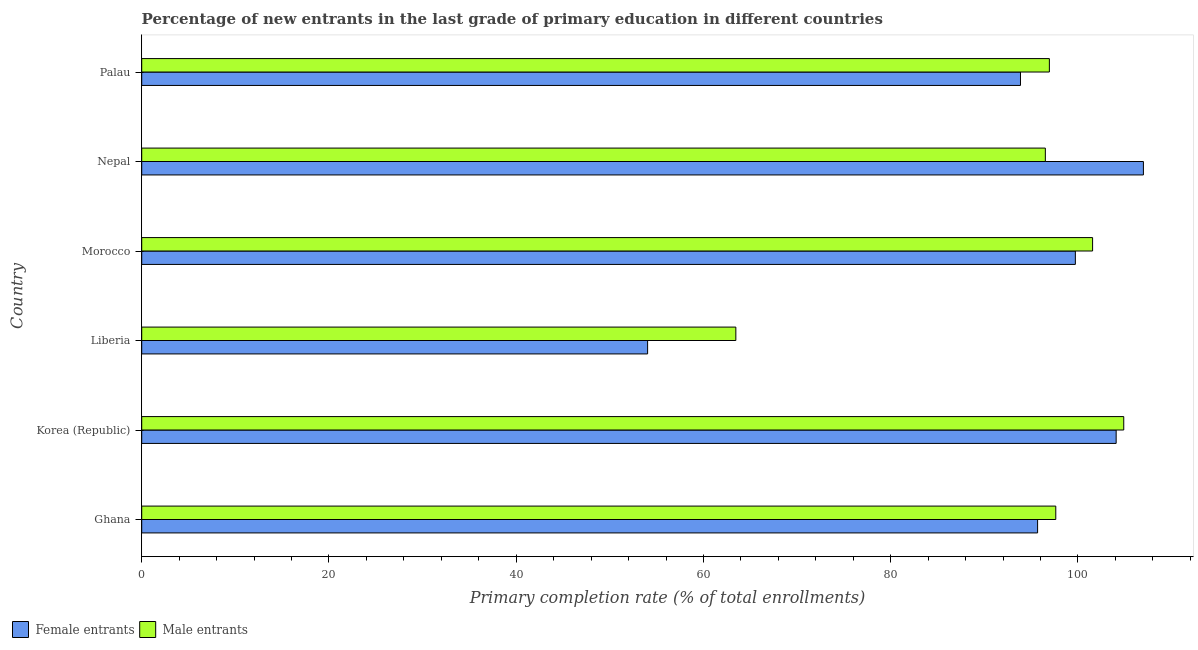How many groups of bars are there?
Provide a succinct answer. 6. Are the number of bars per tick equal to the number of legend labels?
Offer a terse response. Yes. How many bars are there on the 5th tick from the top?
Make the answer very short. 2. How many bars are there on the 4th tick from the bottom?
Provide a short and direct response. 2. What is the primary completion rate of female entrants in Palau?
Offer a very short reply. 93.86. Across all countries, what is the maximum primary completion rate of female entrants?
Keep it short and to the point. 106.99. Across all countries, what is the minimum primary completion rate of male entrants?
Provide a succinct answer. 63.46. In which country was the primary completion rate of male entrants maximum?
Your answer should be compact. Korea (Republic). In which country was the primary completion rate of male entrants minimum?
Your answer should be very brief. Liberia. What is the total primary completion rate of male entrants in the graph?
Make the answer very short. 561. What is the difference between the primary completion rate of male entrants in Liberia and that in Nepal?
Offer a terse response. -33.06. What is the difference between the primary completion rate of male entrants in Morocco and the primary completion rate of female entrants in Nepal?
Your answer should be compact. -5.43. What is the average primary completion rate of female entrants per country?
Ensure brevity in your answer.  92.39. What is the difference between the primary completion rate of male entrants and primary completion rate of female entrants in Palau?
Provide a succinct answer. 3.09. In how many countries, is the primary completion rate of male entrants greater than 84 %?
Provide a succinct answer. 5. What is the ratio of the primary completion rate of male entrants in Korea (Republic) to that in Liberia?
Your answer should be very brief. 1.65. Is the primary completion rate of female entrants in Korea (Republic) less than that in Nepal?
Give a very brief answer. Yes. Is the difference between the primary completion rate of male entrants in Ghana and Liberia greater than the difference between the primary completion rate of female entrants in Ghana and Liberia?
Make the answer very short. No. What is the difference between the highest and the second highest primary completion rate of male entrants?
Your answer should be compact. 3.33. What is the difference between the highest and the lowest primary completion rate of female entrants?
Offer a terse response. 52.96. Is the sum of the primary completion rate of male entrants in Nepal and Palau greater than the maximum primary completion rate of female entrants across all countries?
Make the answer very short. Yes. What does the 1st bar from the top in Nepal represents?
Keep it short and to the point. Male entrants. What does the 2nd bar from the bottom in Korea (Republic) represents?
Make the answer very short. Male entrants. How many bars are there?
Provide a short and direct response. 12. Are all the bars in the graph horizontal?
Provide a succinct answer. Yes. What is the difference between two consecutive major ticks on the X-axis?
Your response must be concise. 20. Are the values on the major ticks of X-axis written in scientific E-notation?
Give a very brief answer. No. How many legend labels are there?
Your answer should be compact. 2. How are the legend labels stacked?
Your answer should be compact. Horizontal. What is the title of the graph?
Your response must be concise. Percentage of new entrants in the last grade of primary education in different countries. Does "Fixed telephone" appear as one of the legend labels in the graph?
Give a very brief answer. No. What is the label or title of the X-axis?
Offer a terse response. Primary completion rate (% of total enrollments). What is the label or title of the Y-axis?
Make the answer very short. Country. What is the Primary completion rate (% of total enrollments) in Female entrants in Ghana?
Your response must be concise. 95.69. What is the Primary completion rate (% of total enrollments) of Male entrants in Ghana?
Offer a terse response. 97.63. What is the Primary completion rate (% of total enrollments) in Female entrants in Korea (Republic)?
Provide a short and direct response. 104.08. What is the Primary completion rate (% of total enrollments) of Male entrants in Korea (Republic)?
Provide a short and direct response. 104.89. What is the Primary completion rate (% of total enrollments) of Female entrants in Liberia?
Ensure brevity in your answer.  54.03. What is the Primary completion rate (% of total enrollments) in Male entrants in Liberia?
Give a very brief answer. 63.46. What is the Primary completion rate (% of total enrollments) of Female entrants in Morocco?
Provide a succinct answer. 99.72. What is the Primary completion rate (% of total enrollments) in Male entrants in Morocco?
Offer a terse response. 101.56. What is the Primary completion rate (% of total enrollments) in Female entrants in Nepal?
Keep it short and to the point. 106.99. What is the Primary completion rate (% of total enrollments) in Male entrants in Nepal?
Offer a very short reply. 96.52. What is the Primary completion rate (% of total enrollments) of Female entrants in Palau?
Your answer should be compact. 93.86. What is the Primary completion rate (% of total enrollments) of Male entrants in Palau?
Provide a short and direct response. 96.95. Across all countries, what is the maximum Primary completion rate (% of total enrollments) of Female entrants?
Your answer should be very brief. 106.99. Across all countries, what is the maximum Primary completion rate (% of total enrollments) in Male entrants?
Make the answer very short. 104.89. Across all countries, what is the minimum Primary completion rate (% of total enrollments) of Female entrants?
Provide a succinct answer. 54.03. Across all countries, what is the minimum Primary completion rate (% of total enrollments) in Male entrants?
Your answer should be very brief. 63.46. What is the total Primary completion rate (% of total enrollments) in Female entrants in the graph?
Give a very brief answer. 554.37. What is the total Primary completion rate (% of total enrollments) in Male entrants in the graph?
Offer a terse response. 561. What is the difference between the Primary completion rate (% of total enrollments) of Female entrants in Ghana and that in Korea (Republic)?
Make the answer very short. -8.39. What is the difference between the Primary completion rate (% of total enrollments) of Male entrants in Ghana and that in Korea (Republic)?
Give a very brief answer. -7.26. What is the difference between the Primary completion rate (% of total enrollments) of Female entrants in Ghana and that in Liberia?
Provide a succinct answer. 41.65. What is the difference between the Primary completion rate (% of total enrollments) of Male entrants in Ghana and that in Liberia?
Provide a succinct answer. 34.17. What is the difference between the Primary completion rate (% of total enrollments) in Female entrants in Ghana and that in Morocco?
Keep it short and to the point. -4.03. What is the difference between the Primary completion rate (% of total enrollments) in Male entrants in Ghana and that in Morocco?
Give a very brief answer. -3.93. What is the difference between the Primary completion rate (% of total enrollments) of Female entrants in Ghana and that in Nepal?
Provide a succinct answer. -11.3. What is the difference between the Primary completion rate (% of total enrollments) in Male entrants in Ghana and that in Nepal?
Offer a very short reply. 1.11. What is the difference between the Primary completion rate (% of total enrollments) of Female entrants in Ghana and that in Palau?
Keep it short and to the point. 1.83. What is the difference between the Primary completion rate (% of total enrollments) of Male entrants in Ghana and that in Palau?
Offer a very short reply. 0.68. What is the difference between the Primary completion rate (% of total enrollments) of Female entrants in Korea (Republic) and that in Liberia?
Your answer should be compact. 50.04. What is the difference between the Primary completion rate (% of total enrollments) in Male entrants in Korea (Republic) and that in Liberia?
Keep it short and to the point. 41.43. What is the difference between the Primary completion rate (% of total enrollments) in Female entrants in Korea (Republic) and that in Morocco?
Give a very brief answer. 4.36. What is the difference between the Primary completion rate (% of total enrollments) in Male entrants in Korea (Republic) and that in Morocco?
Give a very brief answer. 3.33. What is the difference between the Primary completion rate (% of total enrollments) of Female entrants in Korea (Republic) and that in Nepal?
Your response must be concise. -2.91. What is the difference between the Primary completion rate (% of total enrollments) in Male entrants in Korea (Republic) and that in Nepal?
Your answer should be compact. 8.37. What is the difference between the Primary completion rate (% of total enrollments) in Female entrants in Korea (Republic) and that in Palau?
Offer a very short reply. 10.22. What is the difference between the Primary completion rate (% of total enrollments) in Male entrants in Korea (Republic) and that in Palau?
Your answer should be compact. 7.94. What is the difference between the Primary completion rate (% of total enrollments) of Female entrants in Liberia and that in Morocco?
Offer a terse response. -45.69. What is the difference between the Primary completion rate (% of total enrollments) of Male entrants in Liberia and that in Morocco?
Your answer should be very brief. -38.11. What is the difference between the Primary completion rate (% of total enrollments) in Female entrants in Liberia and that in Nepal?
Your answer should be compact. -52.96. What is the difference between the Primary completion rate (% of total enrollments) in Male entrants in Liberia and that in Nepal?
Make the answer very short. -33.06. What is the difference between the Primary completion rate (% of total enrollments) of Female entrants in Liberia and that in Palau?
Keep it short and to the point. -39.83. What is the difference between the Primary completion rate (% of total enrollments) of Male entrants in Liberia and that in Palau?
Provide a succinct answer. -33.49. What is the difference between the Primary completion rate (% of total enrollments) in Female entrants in Morocco and that in Nepal?
Give a very brief answer. -7.27. What is the difference between the Primary completion rate (% of total enrollments) of Male entrants in Morocco and that in Nepal?
Provide a succinct answer. 5.05. What is the difference between the Primary completion rate (% of total enrollments) of Female entrants in Morocco and that in Palau?
Your answer should be compact. 5.86. What is the difference between the Primary completion rate (% of total enrollments) in Male entrants in Morocco and that in Palau?
Provide a succinct answer. 4.62. What is the difference between the Primary completion rate (% of total enrollments) of Female entrants in Nepal and that in Palau?
Offer a very short reply. 13.13. What is the difference between the Primary completion rate (% of total enrollments) in Male entrants in Nepal and that in Palau?
Your answer should be compact. -0.43. What is the difference between the Primary completion rate (% of total enrollments) of Female entrants in Ghana and the Primary completion rate (% of total enrollments) of Male entrants in Korea (Republic)?
Offer a terse response. -9.2. What is the difference between the Primary completion rate (% of total enrollments) in Female entrants in Ghana and the Primary completion rate (% of total enrollments) in Male entrants in Liberia?
Make the answer very short. 32.23. What is the difference between the Primary completion rate (% of total enrollments) in Female entrants in Ghana and the Primary completion rate (% of total enrollments) in Male entrants in Morocco?
Your answer should be compact. -5.87. What is the difference between the Primary completion rate (% of total enrollments) in Female entrants in Ghana and the Primary completion rate (% of total enrollments) in Male entrants in Nepal?
Offer a terse response. -0.83. What is the difference between the Primary completion rate (% of total enrollments) of Female entrants in Ghana and the Primary completion rate (% of total enrollments) of Male entrants in Palau?
Keep it short and to the point. -1.26. What is the difference between the Primary completion rate (% of total enrollments) of Female entrants in Korea (Republic) and the Primary completion rate (% of total enrollments) of Male entrants in Liberia?
Your response must be concise. 40.62. What is the difference between the Primary completion rate (% of total enrollments) in Female entrants in Korea (Republic) and the Primary completion rate (% of total enrollments) in Male entrants in Morocco?
Ensure brevity in your answer.  2.52. What is the difference between the Primary completion rate (% of total enrollments) in Female entrants in Korea (Republic) and the Primary completion rate (% of total enrollments) in Male entrants in Nepal?
Your response must be concise. 7.56. What is the difference between the Primary completion rate (% of total enrollments) in Female entrants in Korea (Republic) and the Primary completion rate (% of total enrollments) in Male entrants in Palau?
Make the answer very short. 7.13. What is the difference between the Primary completion rate (% of total enrollments) of Female entrants in Liberia and the Primary completion rate (% of total enrollments) of Male entrants in Morocco?
Keep it short and to the point. -47.53. What is the difference between the Primary completion rate (% of total enrollments) of Female entrants in Liberia and the Primary completion rate (% of total enrollments) of Male entrants in Nepal?
Provide a succinct answer. -42.48. What is the difference between the Primary completion rate (% of total enrollments) in Female entrants in Liberia and the Primary completion rate (% of total enrollments) in Male entrants in Palau?
Offer a terse response. -42.91. What is the difference between the Primary completion rate (% of total enrollments) of Female entrants in Morocco and the Primary completion rate (% of total enrollments) of Male entrants in Nepal?
Your answer should be very brief. 3.21. What is the difference between the Primary completion rate (% of total enrollments) of Female entrants in Morocco and the Primary completion rate (% of total enrollments) of Male entrants in Palau?
Your answer should be very brief. 2.77. What is the difference between the Primary completion rate (% of total enrollments) of Female entrants in Nepal and the Primary completion rate (% of total enrollments) of Male entrants in Palau?
Your response must be concise. 10.04. What is the average Primary completion rate (% of total enrollments) of Female entrants per country?
Your answer should be very brief. 92.4. What is the average Primary completion rate (% of total enrollments) of Male entrants per country?
Your answer should be compact. 93.5. What is the difference between the Primary completion rate (% of total enrollments) in Female entrants and Primary completion rate (% of total enrollments) in Male entrants in Ghana?
Your answer should be compact. -1.94. What is the difference between the Primary completion rate (% of total enrollments) in Female entrants and Primary completion rate (% of total enrollments) in Male entrants in Korea (Republic)?
Provide a short and direct response. -0.81. What is the difference between the Primary completion rate (% of total enrollments) in Female entrants and Primary completion rate (% of total enrollments) in Male entrants in Liberia?
Your answer should be compact. -9.42. What is the difference between the Primary completion rate (% of total enrollments) of Female entrants and Primary completion rate (% of total enrollments) of Male entrants in Morocco?
Your response must be concise. -1.84. What is the difference between the Primary completion rate (% of total enrollments) of Female entrants and Primary completion rate (% of total enrollments) of Male entrants in Nepal?
Keep it short and to the point. 10.47. What is the difference between the Primary completion rate (% of total enrollments) of Female entrants and Primary completion rate (% of total enrollments) of Male entrants in Palau?
Your response must be concise. -3.09. What is the ratio of the Primary completion rate (% of total enrollments) in Female entrants in Ghana to that in Korea (Republic)?
Your answer should be very brief. 0.92. What is the ratio of the Primary completion rate (% of total enrollments) in Male entrants in Ghana to that in Korea (Republic)?
Offer a terse response. 0.93. What is the ratio of the Primary completion rate (% of total enrollments) in Female entrants in Ghana to that in Liberia?
Your answer should be very brief. 1.77. What is the ratio of the Primary completion rate (% of total enrollments) of Male entrants in Ghana to that in Liberia?
Give a very brief answer. 1.54. What is the ratio of the Primary completion rate (% of total enrollments) of Female entrants in Ghana to that in Morocco?
Your answer should be very brief. 0.96. What is the ratio of the Primary completion rate (% of total enrollments) of Male entrants in Ghana to that in Morocco?
Give a very brief answer. 0.96. What is the ratio of the Primary completion rate (% of total enrollments) in Female entrants in Ghana to that in Nepal?
Give a very brief answer. 0.89. What is the ratio of the Primary completion rate (% of total enrollments) of Male entrants in Ghana to that in Nepal?
Your response must be concise. 1.01. What is the ratio of the Primary completion rate (% of total enrollments) in Female entrants in Ghana to that in Palau?
Provide a succinct answer. 1.02. What is the ratio of the Primary completion rate (% of total enrollments) of Male entrants in Ghana to that in Palau?
Provide a succinct answer. 1.01. What is the ratio of the Primary completion rate (% of total enrollments) in Female entrants in Korea (Republic) to that in Liberia?
Your response must be concise. 1.93. What is the ratio of the Primary completion rate (% of total enrollments) in Male entrants in Korea (Republic) to that in Liberia?
Offer a terse response. 1.65. What is the ratio of the Primary completion rate (% of total enrollments) of Female entrants in Korea (Republic) to that in Morocco?
Give a very brief answer. 1.04. What is the ratio of the Primary completion rate (% of total enrollments) of Male entrants in Korea (Republic) to that in Morocco?
Provide a succinct answer. 1.03. What is the ratio of the Primary completion rate (% of total enrollments) of Female entrants in Korea (Republic) to that in Nepal?
Offer a terse response. 0.97. What is the ratio of the Primary completion rate (% of total enrollments) of Male entrants in Korea (Republic) to that in Nepal?
Your answer should be compact. 1.09. What is the ratio of the Primary completion rate (% of total enrollments) in Female entrants in Korea (Republic) to that in Palau?
Provide a succinct answer. 1.11. What is the ratio of the Primary completion rate (% of total enrollments) in Male entrants in Korea (Republic) to that in Palau?
Offer a terse response. 1.08. What is the ratio of the Primary completion rate (% of total enrollments) of Female entrants in Liberia to that in Morocco?
Your answer should be compact. 0.54. What is the ratio of the Primary completion rate (% of total enrollments) in Male entrants in Liberia to that in Morocco?
Offer a terse response. 0.62. What is the ratio of the Primary completion rate (% of total enrollments) of Female entrants in Liberia to that in Nepal?
Give a very brief answer. 0.51. What is the ratio of the Primary completion rate (% of total enrollments) in Male entrants in Liberia to that in Nepal?
Your answer should be compact. 0.66. What is the ratio of the Primary completion rate (% of total enrollments) of Female entrants in Liberia to that in Palau?
Your answer should be very brief. 0.58. What is the ratio of the Primary completion rate (% of total enrollments) in Male entrants in Liberia to that in Palau?
Your response must be concise. 0.65. What is the ratio of the Primary completion rate (% of total enrollments) in Female entrants in Morocco to that in Nepal?
Your response must be concise. 0.93. What is the ratio of the Primary completion rate (% of total enrollments) in Male entrants in Morocco to that in Nepal?
Your answer should be compact. 1.05. What is the ratio of the Primary completion rate (% of total enrollments) in Male entrants in Morocco to that in Palau?
Your response must be concise. 1.05. What is the ratio of the Primary completion rate (% of total enrollments) of Female entrants in Nepal to that in Palau?
Give a very brief answer. 1.14. What is the difference between the highest and the second highest Primary completion rate (% of total enrollments) of Female entrants?
Give a very brief answer. 2.91. What is the difference between the highest and the second highest Primary completion rate (% of total enrollments) of Male entrants?
Keep it short and to the point. 3.33. What is the difference between the highest and the lowest Primary completion rate (% of total enrollments) in Female entrants?
Your answer should be very brief. 52.96. What is the difference between the highest and the lowest Primary completion rate (% of total enrollments) of Male entrants?
Provide a succinct answer. 41.43. 